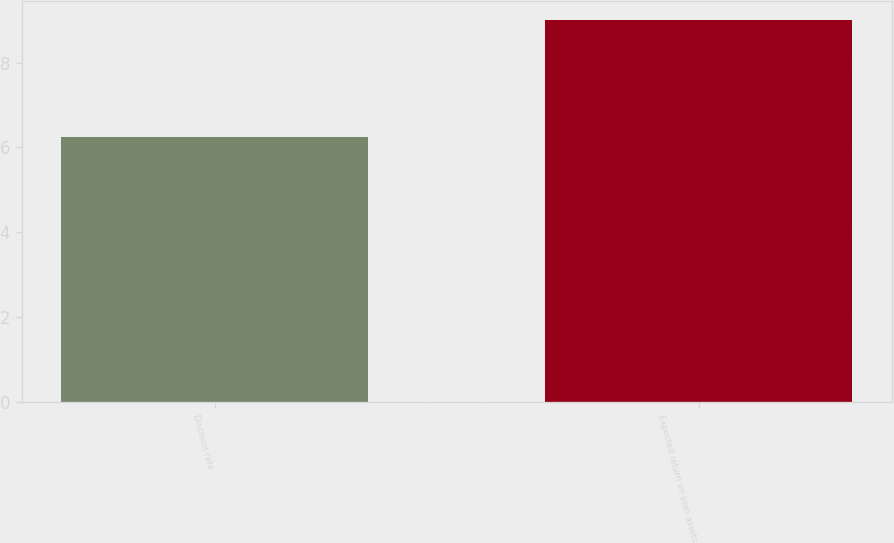Convert chart. <chart><loc_0><loc_0><loc_500><loc_500><bar_chart><fcel>Discount rate<fcel>Expected return on plan assets<nl><fcel>6.25<fcel>9<nl></chart> 